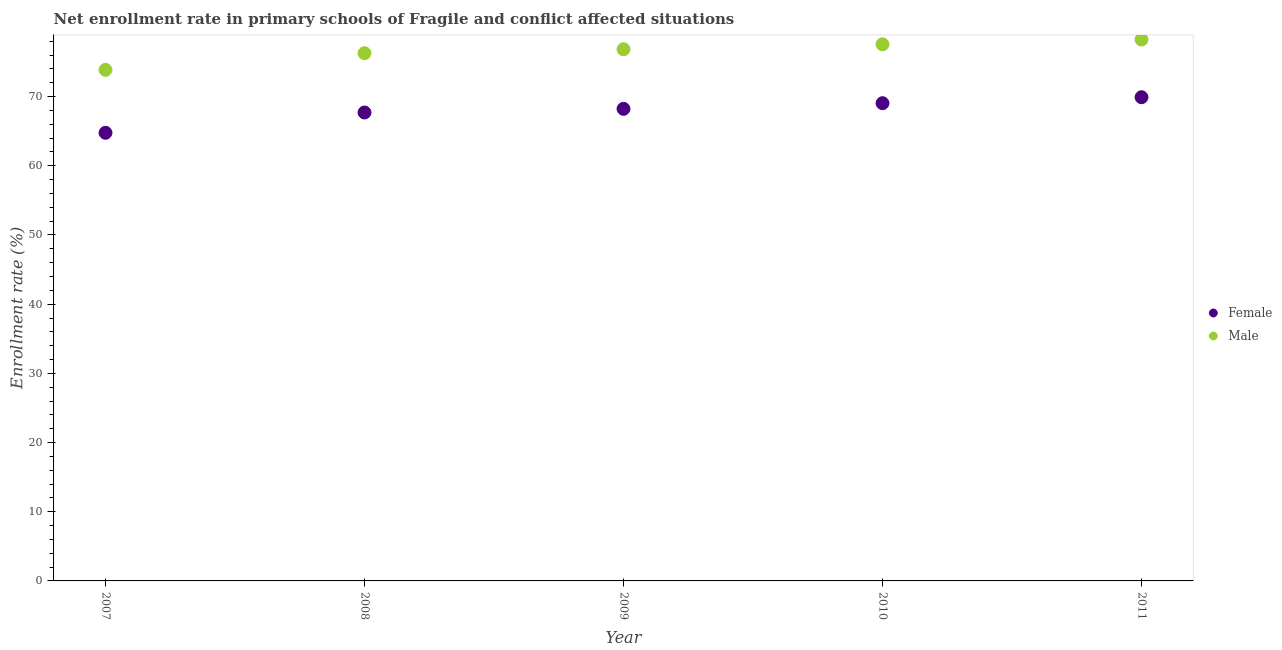Is the number of dotlines equal to the number of legend labels?
Offer a terse response. Yes. What is the enrollment rate of male students in 2011?
Offer a very short reply. 78.25. Across all years, what is the maximum enrollment rate of female students?
Provide a short and direct response. 69.91. Across all years, what is the minimum enrollment rate of male students?
Your answer should be compact. 73.87. In which year was the enrollment rate of female students maximum?
Keep it short and to the point. 2011. In which year was the enrollment rate of female students minimum?
Offer a very short reply. 2007. What is the total enrollment rate of male students in the graph?
Ensure brevity in your answer.  382.81. What is the difference between the enrollment rate of male students in 2008 and that in 2011?
Offer a very short reply. -1.97. What is the difference between the enrollment rate of male students in 2011 and the enrollment rate of female students in 2008?
Offer a terse response. 10.55. What is the average enrollment rate of male students per year?
Ensure brevity in your answer.  76.56. In the year 2007, what is the difference between the enrollment rate of female students and enrollment rate of male students?
Make the answer very short. -9.1. In how many years, is the enrollment rate of female students greater than 32 %?
Provide a succinct answer. 5. What is the ratio of the enrollment rate of male students in 2007 to that in 2010?
Make the answer very short. 0.95. What is the difference between the highest and the second highest enrollment rate of female students?
Ensure brevity in your answer.  0.86. What is the difference between the highest and the lowest enrollment rate of female students?
Offer a terse response. 5.14. Is the enrollment rate of female students strictly greater than the enrollment rate of male students over the years?
Ensure brevity in your answer.  No. Is the enrollment rate of male students strictly less than the enrollment rate of female students over the years?
Offer a terse response. No. How many dotlines are there?
Your response must be concise. 2. How many years are there in the graph?
Your response must be concise. 5. What is the difference between two consecutive major ticks on the Y-axis?
Provide a short and direct response. 10. Does the graph contain any zero values?
Offer a terse response. No. How many legend labels are there?
Give a very brief answer. 2. What is the title of the graph?
Your answer should be compact. Net enrollment rate in primary schools of Fragile and conflict affected situations. Does "Diarrhea" appear as one of the legend labels in the graph?
Your response must be concise. No. What is the label or title of the X-axis?
Your answer should be compact. Year. What is the label or title of the Y-axis?
Make the answer very short. Enrollment rate (%). What is the Enrollment rate (%) in Female in 2007?
Ensure brevity in your answer.  64.77. What is the Enrollment rate (%) in Male in 2007?
Provide a succinct answer. 73.87. What is the Enrollment rate (%) in Female in 2008?
Keep it short and to the point. 67.71. What is the Enrollment rate (%) of Male in 2008?
Make the answer very short. 76.28. What is the Enrollment rate (%) of Female in 2009?
Give a very brief answer. 68.23. What is the Enrollment rate (%) of Male in 2009?
Give a very brief answer. 76.85. What is the Enrollment rate (%) in Female in 2010?
Give a very brief answer. 69.05. What is the Enrollment rate (%) of Male in 2010?
Provide a succinct answer. 77.56. What is the Enrollment rate (%) in Female in 2011?
Ensure brevity in your answer.  69.91. What is the Enrollment rate (%) of Male in 2011?
Offer a terse response. 78.25. Across all years, what is the maximum Enrollment rate (%) in Female?
Provide a succinct answer. 69.91. Across all years, what is the maximum Enrollment rate (%) in Male?
Offer a terse response. 78.25. Across all years, what is the minimum Enrollment rate (%) in Female?
Provide a succinct answer. 64.77. Across all years, what is the minimum Enrollment rate (%) in Male?
Provide a succinct answer. 73.87. What is the total Enrollment rate (%) of Female in the graph?
Your response must be concise. 339.68. What is the total Enrollment rate (%) in Male in the graph?
Your answer should be very brief. 382.81. What is the difference between the Enrollment rate (%) in Female in 2007 and that in 2008?
Ensure brevity in your answer.  -2.93. What is the difference between the Enrollment rate (%) of Male in 2007 and that in 2008?
Your answer should be compact. -2.41. What is the difference between the Enrollment rate (%) in Female in 2007 and that in 2009?
Provide a short and direct response. -3.46. What is the difference between the Enrollment rate (%) of Male in 2007 and that in 2009?
Your answer should be very brief. -2.98. What is the difference between the Enrollment rate (%) of Female in 2007 and that in 2010?
Your answer should be very brief. -4.28. What is the difference between the Enrollment rate (%) in Male in 2007 and that in 2010?
Keep it short and to the point. -3.69. What is the difference between the Enrollment rate (%) in Female in 2007 and that in 2011?
Give a very brief answer. -5.14. What is the difference between the Enrollment rate (%) of Male in 2007 and that in 2011?
Make the answer very short. -4.38. What is the difference between the Enrollment rate (%) in Female in 2008 and that in 2009?
Provide a succinct answer. -0.53. What is the difference between the Enrollment rate (%) of Male in 2008 and that in 2009?
Keep it short and to the point. -0.57. What is the difference between the Enrollment rate (%) of Female in 2008 and that in 2010?
Provide a succinct answer. -1.35. What is the difference between the Enrollment rate (%) of Male in 2008 and that in 2010?
Your response must be concise. -1.28. What is the difference between the Enrollment rate (%) of Female in 2008 and that in 2011?
Ensure brevity in your answer.  -2.21. What is the difference between the Enrollment rate (%) of Male in 2008 and that in 2011?
Provide a short and direct response. -1.97. What is the difference between the Enrollment rate (%) in Female in 2009 and that in 2010?
Provide a short and direct response. -0.82. What is the difference between the Enrollment rate (%) of Male in 2009 and that in 2010?
Provide a short and direct response. -0.71. What is the difference between the Enrollment rate (%) of Female in 2009 and that in 2011?
Provide a succinct answer. -1.68. What is the difference between the Enrollment rate (%) in Male in 2009 and that in 2011?
Your answer should be compact. -1.4. What is the difference between the Enrollment rate (%) in Female in 2010 and that in 2011?
Offer a very short reply. -0.86. What is the difference between the Enrollment rate (%) of Male in 2010 and that in 2011?
Ensure brevity in your answer.  -0.69. What is the difference between the Enrollment rate (%) in Female in 2007 and the Enrollment rate (%) in Male in 2008?
Give a very brief answer. -11.51. What is the difference between the Enrollment rate (%) in Female in 2007 and the Enrollment rate (%) in Male in 2009?
Provide a succinct answer. -12.08. What is the difference between the Enrollment rate (%) in Female in 2007 and the Enrollment rate (%) in Male in 2010?
Make the answer very short. -12.79. What is the difference between the Enrollment rate (%) in Female in 2007 and the Enrollment rate (%) in Male in 2011?
Offer a very short reply. -13.48. What is the difference between the Enrollment rate (%) of Female in 2008 and the Enrollment rate (%) of Male in 2009?
Give a very brief answer. -9.14. What is the difference between the Enrollment rate (%) of Female in 2008 and the Enrollment rate (%) of Male in 2010?
Your response must be concise. -9.86. What is the difference between the Enrollment rate (%) of Female in 2008 and the Enrollment rate (%) of Male in 2011?
Keep it short and to the point. -10.55. What is the difference between the Enrollment rate (%) of Female in 2009 and the Enrollment rate (%) of Male in 2010?
Give a very brief answer. -9.33. What is the difference between the Enrollment rate (%) of Female in 2009 and the Enrollment rate (%) of Male in 2011?
Your answer should be very brief. -10.02. What is the difference between the Enrollment rate (%) of Female in 2010 and the Enrollment rate (%) of Male in 2011?
Keep it short and to the point. -9.2. What is the average Enrollment rate (%) of Female per year?
Provide a succinct answer. 67.94. What is the average Enrollment rate (%) in Male per year?
Provide a succinct answer. 76.56. In the year 2007, what is the difference between the Enrollment rate (%) of Female and Enrollment rate (%) of Male?
Provide a succinct answer. -9.1. In the year 2008, what is the difference between the Enrollment rate (%) in Female and Enrollment rate (%) in Male?
Offer a terse response. -8.58. In the year 2009, what is the difference between the Enrollment rate (%) in Female and Enrollment rate (%) in Male?
Provide a short and direct response. -8.62. In the year 2010, what is the difference between the Enrollment rate (%) of Female and Enrollment rate (%) of Male?
Provide a short and direct response. -8.51. In the year 2011, what is the difference between the Enrollment rate (%) of Female and Enrollment rate (%) of Male?
Offer a very short reply. -8.34. What is the ratio of the Enrollment rate (%) of Female in 2007 to that in 2008?
Your response must be concise. 0.96. What is the ratio of the Enrollment rate (%) in Male in 2007 to that in 2008?
Your answer should be compact. 0.97. What is the ratio of the Enrollment rate (%) in Female in 2007 to that in 2009?
Make the answer very short. 0.95. What is the ratio of the Enrollment rate (%) in Male in 2007 to that in 2009?
Offer a very short reply. 0.96. What is the ratio of the Enrollment rate (%) in Female in 2007 to that in 2010?
Keep it short and to the point. 0.94. What is the ratio of the Enrollment rate (%) in Female in 2007 to that in 2011?
Provide a short and direct response. 0.93. What is the ratio of the Enrollment rate (%) of Male in 2007 to that in 2011?
Your response must be concise. 0.94. What is the ratio of the Enrollment rate (%) in Male in 2008 to that in 2009?
Ensure brevity in your answer.  0.99. What is the ratio of the Enrollment rate (%) of Female in 2008 to that in 2010?
Your answer should be very brief. 0.98. What is the ratio of the Enrollment rate (%) of Male in 2008 to that in 2010?
Provide a succinct answer. 0.98. What is the ratio of the Enrollment rate (%) in Female in 2008 to that in 2011?
Provide a short and direct response. 0.97. What is the ratio of the Enrollment rate (%) in Male in 2008 to that in 2011?
Give a very brief answer. 0.97. What is the ratio of the Enrollment rate (%) of Male in 2009 to that in 2010?
Give a very brief answer. 0.99. What is the ratio of the Enrollment rate (%) of Male in 2009 to that in 2011?
Offer a terse response. 0.98. What is the ratio of the Enrollment rate (%) in Female in 2010 to that in 2011?
Ensure brevity in your answer.  0.99. What is the ratio of the Enrollment rate (%) in Male in 2010 to that in 2011?
Provide a short and direct response. 0.99. What is the difference between the highest and the second highest Enrollment rate (%) of Female?
Ensure brevity in your answer.  0.86. What is the difference between the highest and the second highest Enrollment rate (%) of Male?
Offer a very short reply. 0.69. What is the difference between the highest and the lowest Enrollment rate (%) of Female?
Provide a succinct answer. 5.14. What is the difference between the highest and the lowest Enrollment rate (%) in Male?
Make the answer very short. 4.38. 